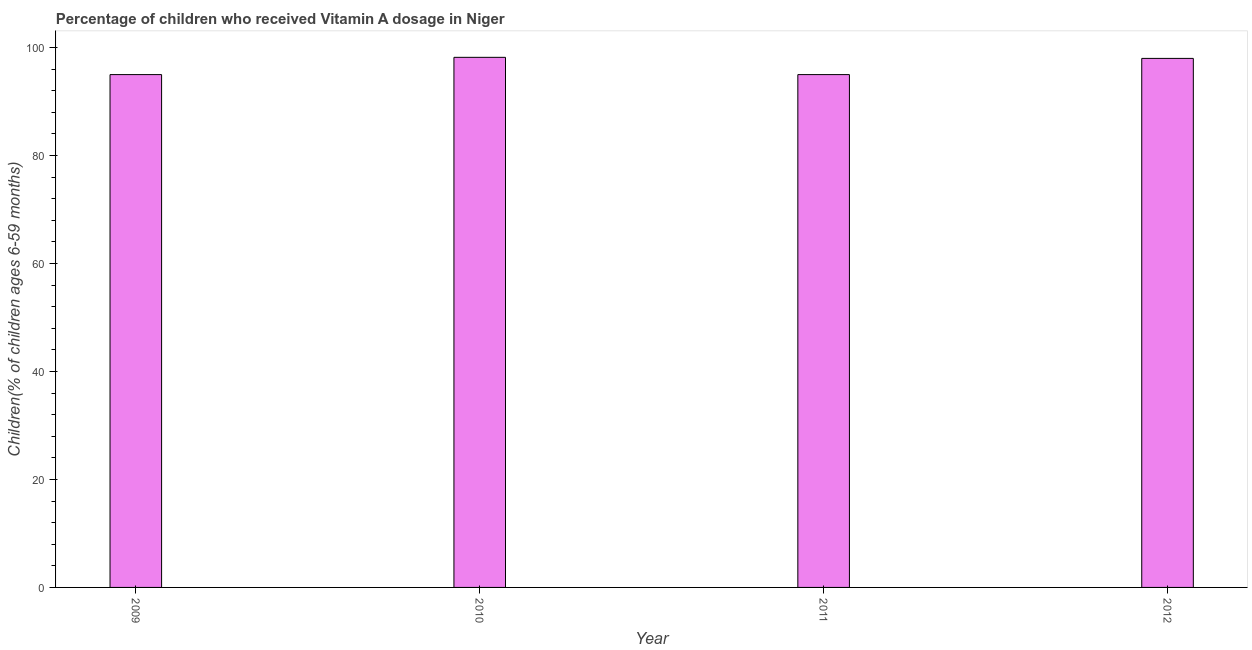Does the graph contain any zero values?
Offer a very short reply. No. What is the title of the graph?
Give a very brief answer. Percentage of children who received Vitamin A dosage in Niger. What is the label or title of the X-axis?
Ensure brevity in your answer.  Year. What is the label or title of the Y-axis?
Offer a terse response. Children(% of children ages 6-59 months). Across all years, what is the maximum vitamin a supplementation coverage rate?
Your response must be concise. 98.2. What is the sum of the vitamin a supplementation coverage rate?
Ensure brevity in your answer.  386.2. What is the difference between the vitamin a supplementation coverage rate in 2010 and 2011?
Keep it short and to the point. 3.2. What is the average vitamin a supplementation coverage rate per year?
Offer a terse response. 96.55. What is the median vitamin a supplementation coverage rate?
Give a very brief answer. 96.5. In how many years, is the vitamin a supplementation coverage rate greater than 72 %?
Provide a succinct answer. 4. Do a majority of the years between 2009 and 2011 (inclusive) have vitamin a supplementation coverage rate greater than 8 %?
Ensure brevity in your answer.  Yes. What is the ratio of the vitamin a supplementation coverage rate in 2009 to that in 2012?
Ensure brevity in your answer.  0.97. What is the difference between the highest and the second highest vitamin a supplementation coverage rate?
Ensure brevity in your answer.  0.2. Is the sum of the vitamin a supplementation coverage rate in 2009 and 2011 greater than the maximum vitamin a supplementation coverage rate across all years?
Offer a very short reply. Yes. What is the difference between the highest and the lowest vitamin a supplementation coverage rate?
Your answer should be compact. 3.2. How many bars are there?
Make the answer very short. 4. How many years are there in the graph?
Your response must be concise. 4. Are the values on the major ticks of Y-axis written in scientific E-notation?
Offer a very short reply. No. What is the Children(% of children ages 6-59 months) of 2010?
Make the answer very short. 98.2. What is the Children(% of children ages 6-59 months) of 2011?
Your answer should be very brief. 95. What is the difference between the Children(% of children ages 6-59 months) in 2009 and 2010?
Make the answer very short. -3.2. What is the difference between the Children(% of children ages 6-59 months) in 2009 and 2011?
Keep it short and to the point. 0. What is the difference between the Children(% of children ages 6-59 months) in 2009 and 2012?
Your response must be concise. -3. What is the difference between the Children(% of children ages 6-59 months) in 2010 and 2011?
Your answer should be compact. 3.2. What is the difference between the Children(% of children ages 6-59 months) in 2010 and 2012?
Your answer should be very brief. 0.2. What is the ratio of the Children(% of children ages 6-59 months) in 2009 to that in 2011?
Provide a succinct answer. 1. What is the ratio of the Children(% of children ages 6-59 months) in 2010 to that in 2011?
Keep it short and to the point. 1.03. What is the ratio of the Children(% of children ages 6-59 months) in 2010 to that in 2012?
Give a very brief answer. 1. What is the ratio of the Children(% of children ages 6-59 months) in 2011 to that in 2012?
Offer a very short reply. 0.97. 